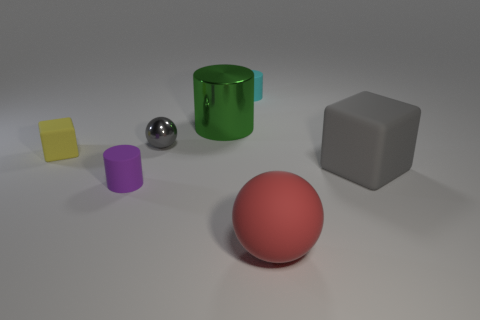How many other things are the same color as the tiny ball?
Make the answer very short. 1. There is a thing that is both left of the cyan rubber cylinder and behind the small ball; what is its size?
Ensure brevity in your answer.  Large. There is a gray shiny thing that is the same size as the yellow object; what shape is it?
Provide a succinct answer. Sphere. There is a big green shiny cylinder behind the tiny purple rubber cylinder; are there any small cylinders that are in front of it?
Provide a succinct answer. Yes. There is a big thing that is the same shape as the small cyan matte object; what color is it?
Offer a terse response. Green. Does the matte cube to the right of the gray ball have the same color as the tiny metallic sphere?
Ensure brevity in your answer.  Yes. How many objects are either balls that are to the left of the large red ball or big blue metallic cylinders?
Keep it short and to the point. 1. What is the material of the ball that is in front of the gray thing that is to the right of the sphere in front of the tiny ball?
Keep it short and to the point. Rubber. Is the number of matte blocks right of the small purple matte object greater than the number of blocks that are behind the green metallic cylinder?
Keep it short and to the point. Yes. How many spheres are either blue things or small things?
Your response must be concise. 1. 